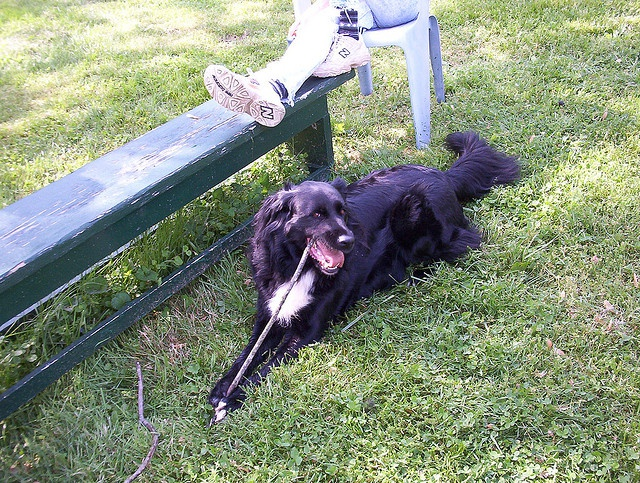Describe the objects in this image and their specific colors. I can see bench in beige, purple, lavender, black, and darkblue tones, dog in beige, black, navy, and purple tones, people in beige, white, lavender, darkgray, and blue tones, and chair in beige, lavender, darkgray, and gray tones in this image. 